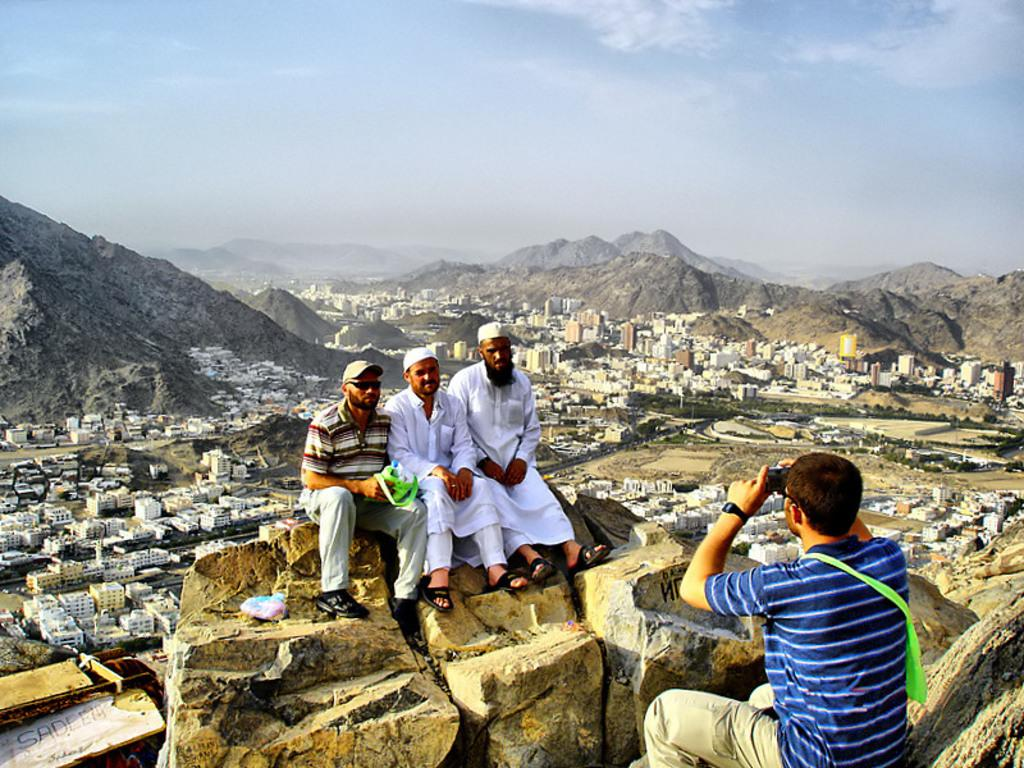What are the people in the image doing? There are people sitting on a rock in the image. Can you describe the man in the image? There is a man sitting and holding a camera in his hand. What can be seen in the distance in the image? There are buildings and hills visible in the background of the image. What type of attraction can be seen in the river in the image? There is no river present in the image, so it is not possible to determine if there is an attraction or not. 